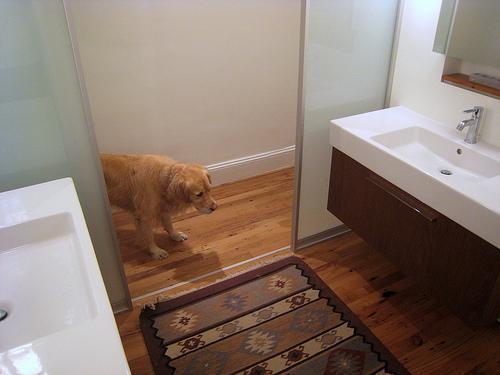How many dogs are there?
Give a very brief answer. 1. How many sinks are there?
Give a very brief answer. 2. 